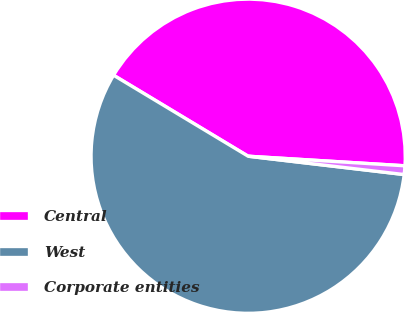Convert chart to OTSL. <chart><loc_0><loc_0><loc_500><loc_500><pie_chart><fcel>Central<fcel>West<fcel>Corporate entities<nl><fcel>42.35%<fcel>56.76%<fcel>0.89%<nl></chart> 